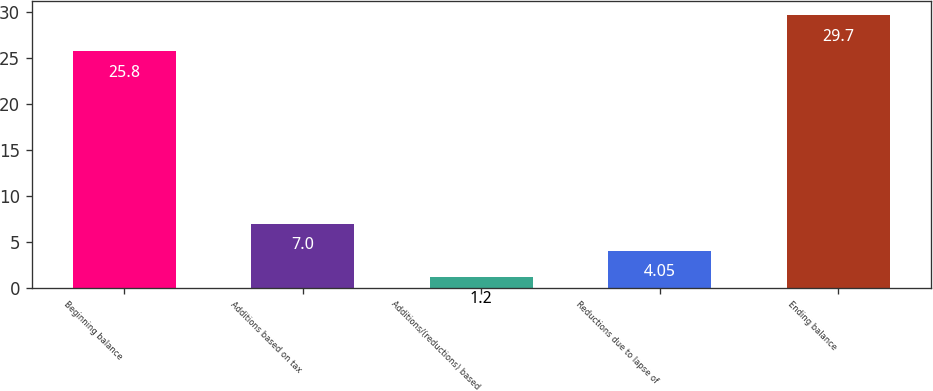Convert chart. <chart><loc_0><loc_0><loc_500><loc_500><bar_chart><fcel>Beginning balance<fcel>Additions based on tax<fcel>Additions/(reductions) based<fcel>Reductions due to lapse of<fcel>Ending balance<nl><fcel>25.8<fcel>7<fcel>1.2<fcel>4.05<fcel>29.7<nl></chart> 